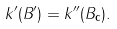<formula> <loc_0><loc_0><loc_500><loc_500>k ^ { \prime } ( B ^ { \prime } ) = k ^ { \prime \prime } ( B _ { \mathbf c } ) .</formula> 